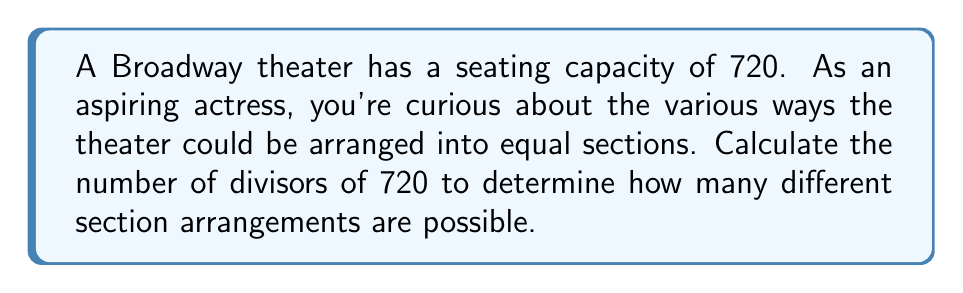Can you answer this question? To find the number of divisors of 720, we'll follow these steps:

1) First, let's find the prime factorization of 720:
   $720 = 2^4 \times 3^2 \times 5$

2) To calculate the number of divisors, we use the divisor function formula:
   $d(n) = (a_1 + 1)(a_2 + 1)...(a_k + 1)$
   where $a_1, a_2, ..., a_k$ are the exponents in the prime factorization.

3) In this case, we have:
   $d(720) = (4 + 1)(2 + 1)(1 + 1)$

4) Let's calculate:
   $d(720) = 5 \times 3 \times 2 = 30$

Therefore, there are 30 divisors of 720, which means the theater could be arranged into 30 different numbers of equal sections.

Some possible arrangements include:
1, 2, 3, 4, 5, 6, 8, 9, 10, 12, 15, 16, 18, 20, 24, 30, 36, 40, 45, 48, 60, 72, 80, 90, 120, 144, 180, 240, 360, and 720 sections.

Each of these numbers represents a possible way to divide the theater into equal sections, giving you insight into the various seating arrangements you might encounter in your future Broadway career.
Answer: 30 